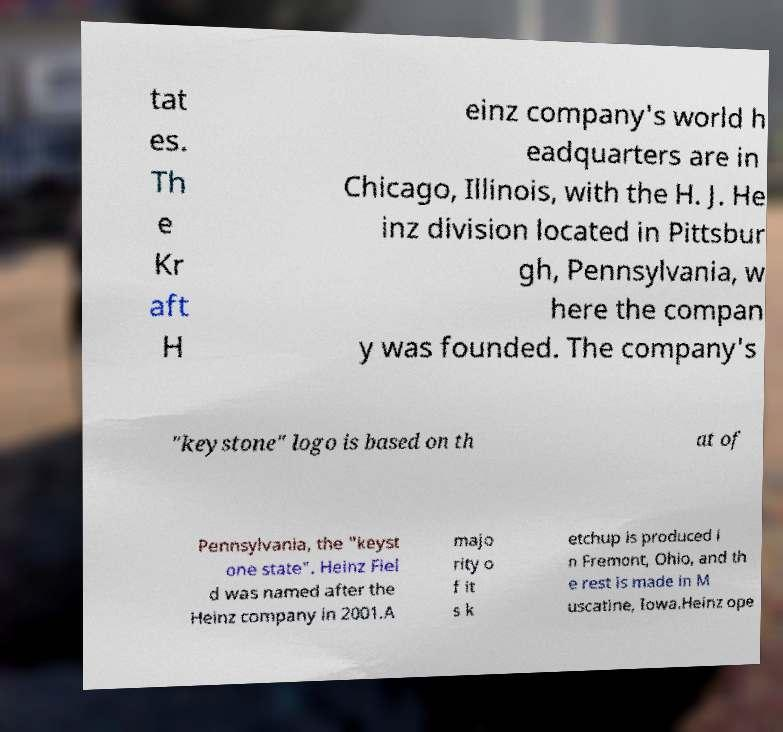What messages or text are displayed in this image? I need them in a readable, typed format. tat es. Th e Kr aft H einz company's world h eadquarters are in Chicago, Illinois, with the H. J. He inz division located in Pittsbur gh, Pennsylvania, w here the compan y was founded. The company's "keystone" logo is based on th at of Pennsylvania, the "keyst one state". Heinz Fiel d was named after the Heinz company in 2001.A majo rity o f it s k etchup is produced i n Fremont, Ohio, and th e rest is made in M uscatine, Iowa.Heinz ope 